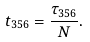<formula> <loc_0><loc_0><loc_500><loc_500>t _ { 3 5 6 } = \frac { \tau _ { 3 5 6 } } { N } .</formula> 